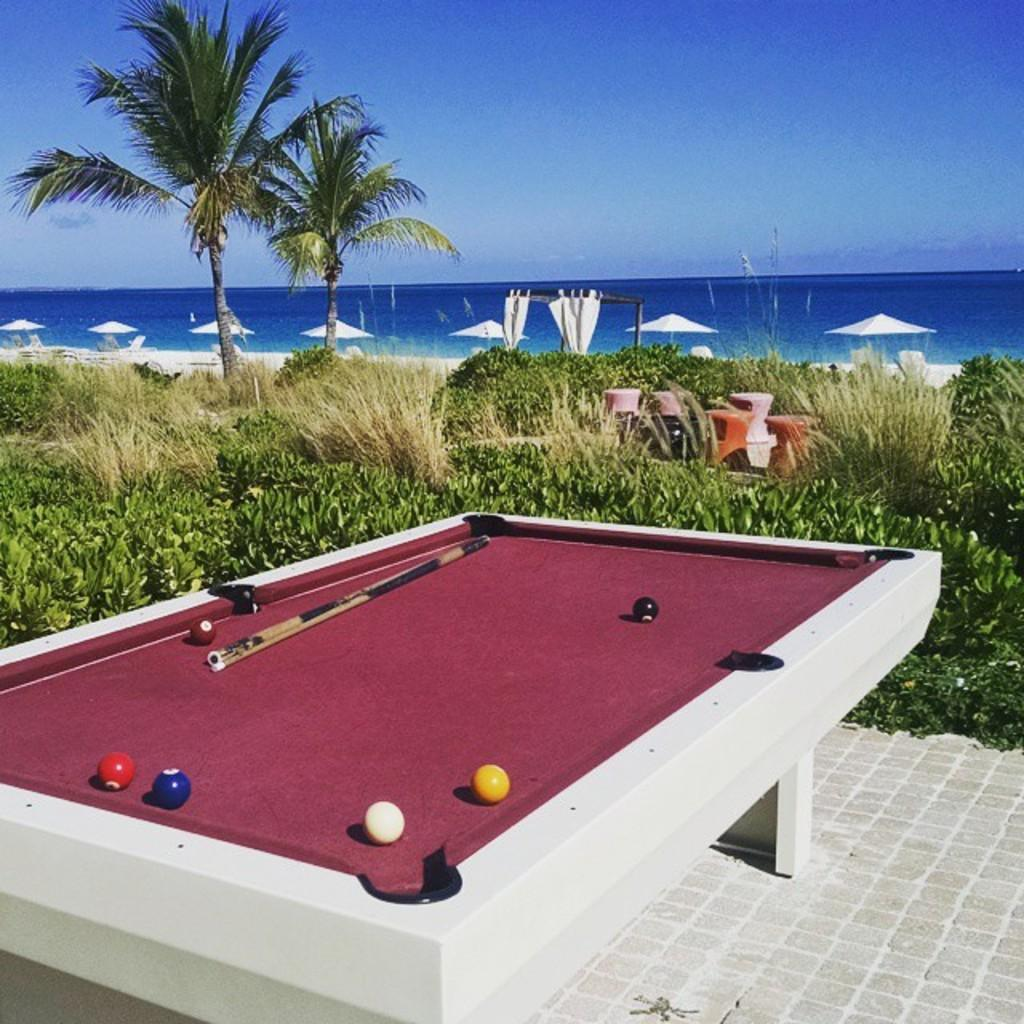What type of table is in the image? There is a snooker table in the image. What equipment is used for playing on the snooker table? There are snooker sticks in the image. What can be seen in the background of the image? There are plants, a tree, and a sea in the background of the image. What is the condition of the sky in the image? The sky is clear in the image. How many apples are hanging from the tree in the image? There is no tree with apples in the image; the tree in the background is not bearing any fruit. What type of shop can be seen near the snooker table in the image? There is no shop visible in the image; it only features a snooker table, snooker sticks, and the background elements. 